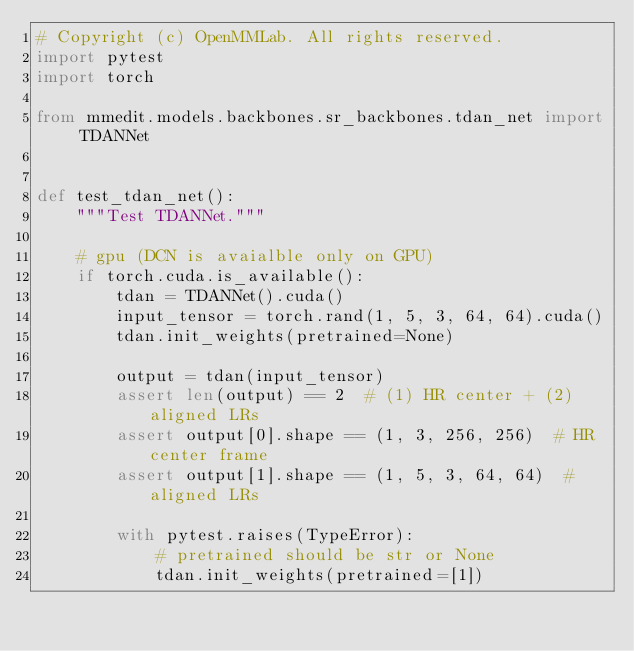Convert code to text. <code><loc_0><loc_0><loc_500><loc_500><_Python_># Copyright (c) OpenMMLab. All rights reserved.
import pytest
import torch

from mmedit.models.backbones.sr_backbones.tdan_net import TDANNet


def test_tdan_net():
    """Test TDANNet."""

    # gpu (DCN is avaialble only on GPU)
    if torch.cuda.is_available():
        tdan = TDANNet().cuda()
        input_tensor = torch.rand(1, 5, 3, 64, 64).cuda()
        tdan.init_weights(pretrained=None)

        output = tdan(input_tensor)
        assert len(output) == 2  # (1) HR center + (2) aligned LRs
        assert output[0].shape == (1, 3, 256, 256)  # HR center frame
        assert output[1].shape == (1, 5, 3, 64, 64)  # aligned LRs

        with pytest.raises(TypeError):
            # pretrained should be str or None
            tdan.init_weights(pretrained=[1])
</code> 